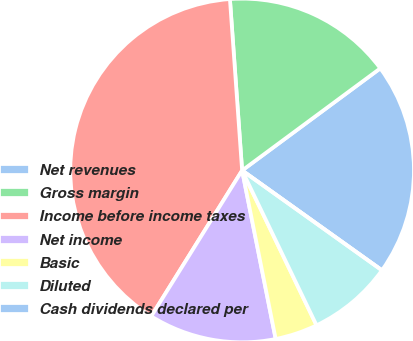Convert chart to OTSL. <chart><loc_0><loc_0><loc_500><loc_500><pie_chart><fcel>Net revenues<fcel>Gross margin<fcel>Income before income taxes<fcel>Net income<fcel>Basic<fcel>Diluted<fcel>Cash dividends declared per<nl><fcel>20.0%<fcel>16.0%<fcel>40.0%<fcel>12.0%<fcel>4.0%<fcel>8.0%<fcel>0.0%<nl></chart> 